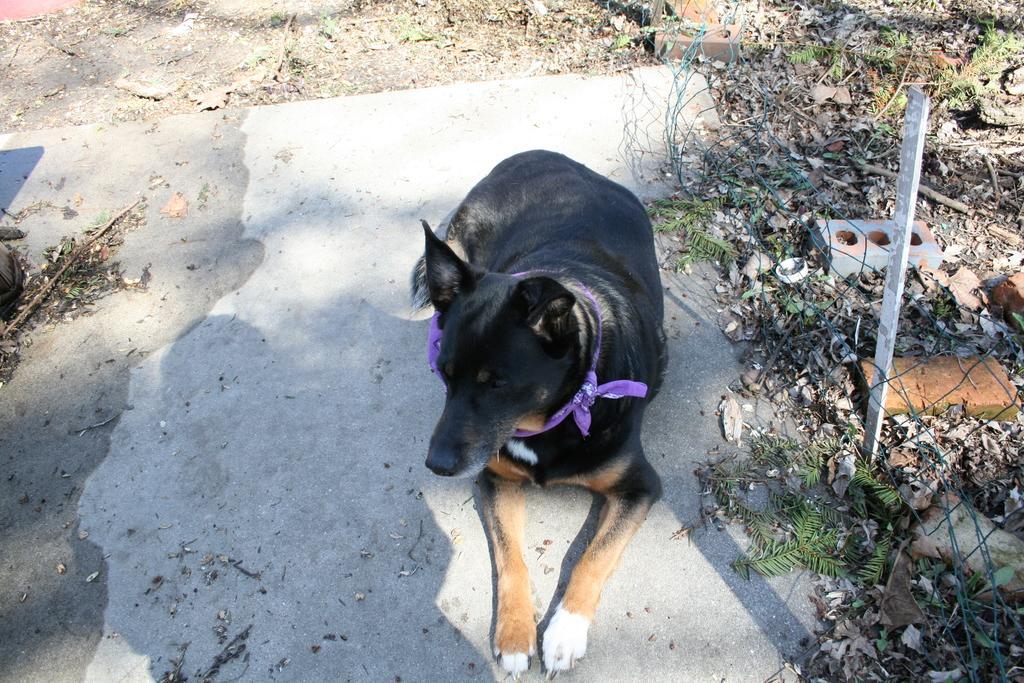Could you give a brief overview of what you see in this image? In this picture I can see the animal sitting on the surface. I can see the metal grill fence on the right side. 